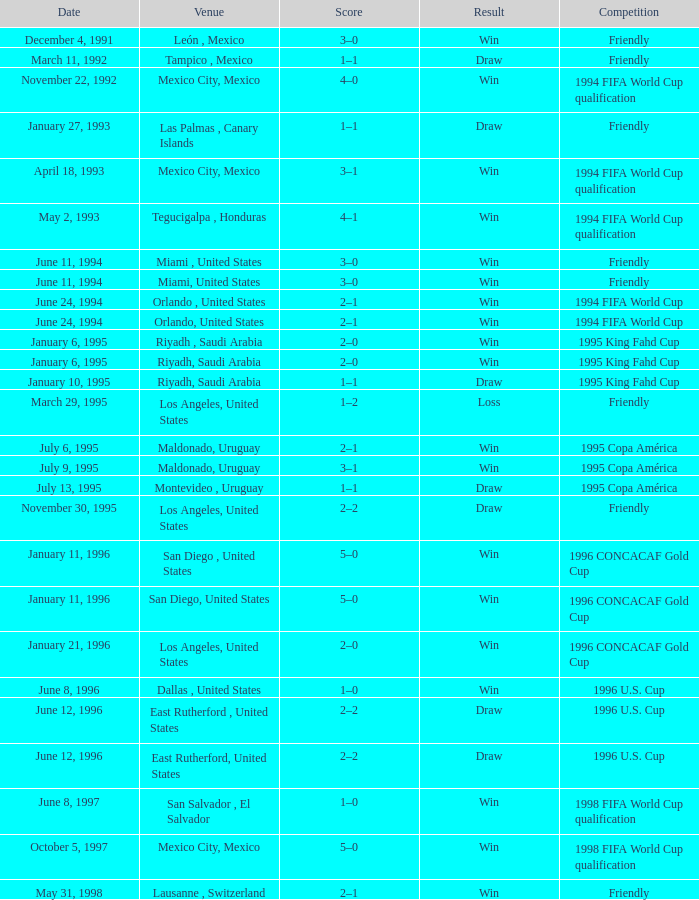What is Score, when Venue is Riyadh, Saudi Arabia, and when Result is "Win"? 2–0, 2–0. 